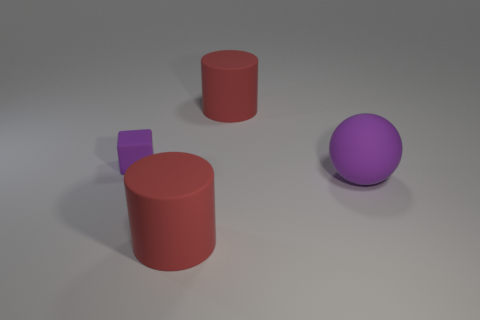Add 2 tiny objects. How many objects exist? 6 Subtract all spheres. How many objects are left? 3 Subtract 1 balls. How many balls are left? 0 Add 3 tiny purple blocks. How many tiny purple blocks are left? 4 Add 2 purple spheres. How many purple spheres exist? 3 Subtract 0 yellow balls. How many objects are left? 4 Subtract all purple cylinders. Subtract all brown blocks. How many cylinders are left? 2 Subtract all blue metal blocks. Subtract all purple things. How many objects are left? 2 